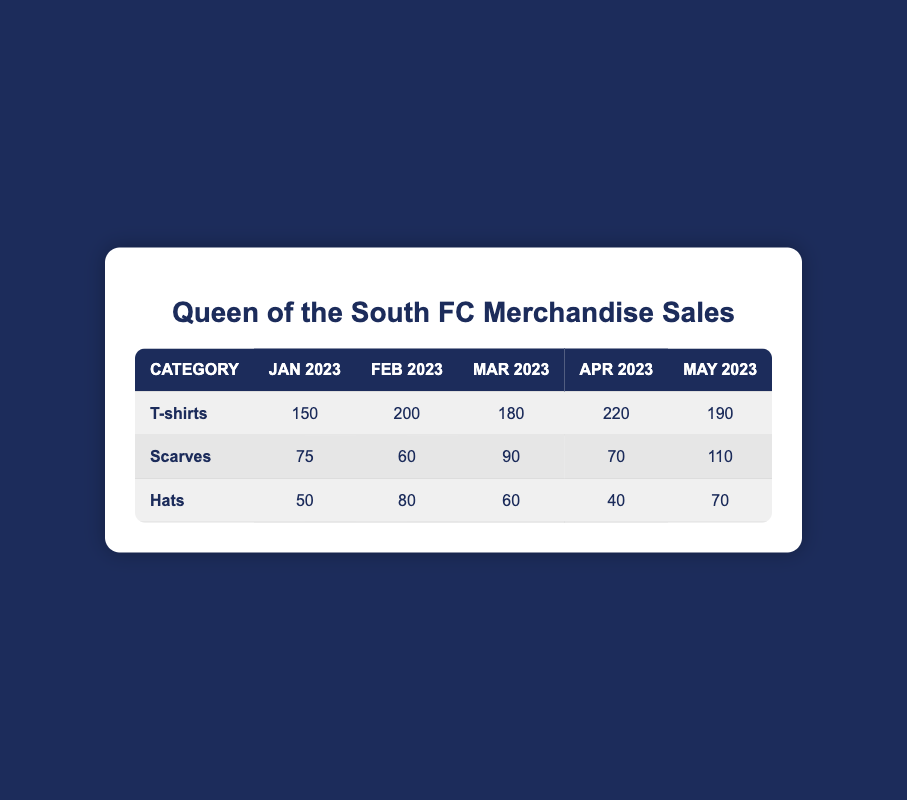What was the total sales for T-shirts in April 2023? The sales for T-shirts in April 2023 is 220. Therefore, the total sales for T-shirts in that month is 220.
Answer: 220 Which category had the highest sales in May 2023? In May 2023, T-shirts sold 190, Scarves sold 110, and Hats sold 70. The category with the highest sales is T-shirts at 190.
Answer: T-shirts What is the average sales of Scarves from January to April 2023? The sales for Scarves are 75 (Jan) + 60 (Feb) + 90 (Mar) + 70 (Apr) = 295. To find the average, divide 295 by 4, resulting in approximately 73.75.
Answer: Approximately 73.75 Did Hats have higher sales in February 2023 compared to January 2023? Hats sold 80 in February and 50 in January. Since 80 is greater than 50, Hats did have higher sales in February compared to January.
Answer: Yes What is the difference in sales of T-shirts between March and January 2023? T-shirts sold 180 in March and 150 in January. The difference is 180 - 150 = 30.
Answer: 30 How many total Hats were sold from January to May 2023? Hats sold 50 (Jan) + 80 (Feb) + 60 (Mar) + 40 (Apr) + 70 (May) = 300. Therefore, the total sales of Hats is 300.
Answer: 300 Which month had the lowest sales in the Scarves category? January had 75, February had 60, March had 90, April had 70, and May had 110. The lowest sales occurred in February with 60.
Answer: February Was the sale of T-shirts consistent throughout the months? Observing the T-shirt sales: 150, 200, 180, 220, 190, there is variability which indicates inconsistency in the sales.
Answer: No What was the sales trend for T-shirts over the five months? The T-shirt sales showed an increasing trend from January to April, peaking at 220, followed by a slight decrease to 190 in May. This indicates that T-shirts were generally popular but slightly declined in May.
Answer: Increasing then slightly decreased 